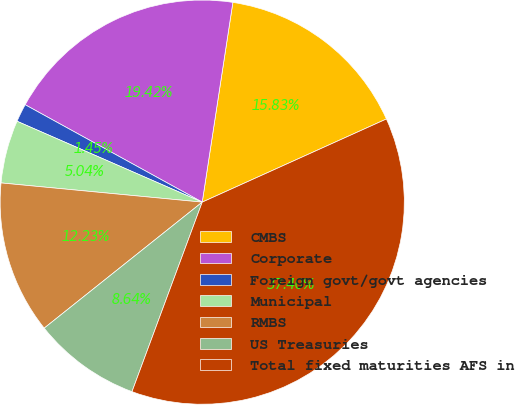Convert chart to OTSL. <chart><loc_0><loc_0><loc_500><loc_500><pie_chart><fcel>CMBS<fcel>Corporate<fcel>Foreign govt/govt agencies<fcel>Municipal<fcel>RMBS<fcel>US Treasuries<fcel>Total fixed maturities AFS in<nl><fcel>15.83%<fcel>19.42%<fcel>1.45%<fcel>5.04%<fcel>12.23%<fcel>8.64%<fcel>37.4%<nl></chart> 